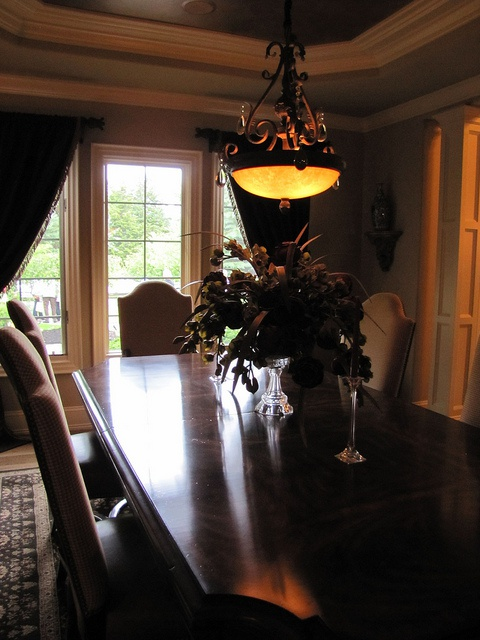Describe the objects in this image and their specific colors. I can see dining table in maroon, black, white, and gray tones, potted plant in maroon, black, and white tones, chair in maroon, black, darkgray, and gray tones, couch in maroon, black, and gray tones, and chair in maroon, black, and brown tones in this image. 